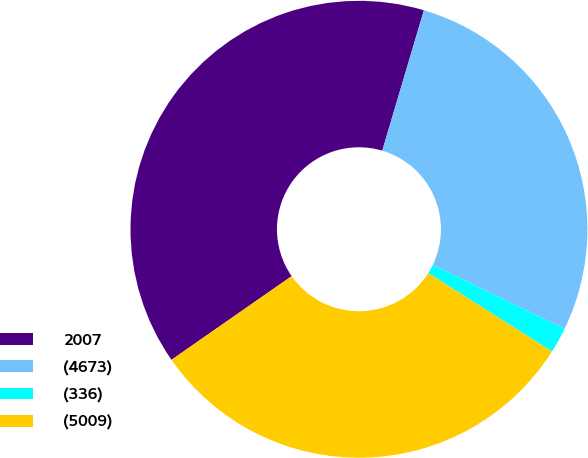Convert chart. <chart><loc_0><loc_0><loc_500><loc_500><pie_chart><fcel>2007<fcel>(4673)<fcel>(336)<fcel>(5009)<nl><fcel>39.27%<fcel>27.58%<fcel>1.82%<fcel>31.33%<nl></chart> 